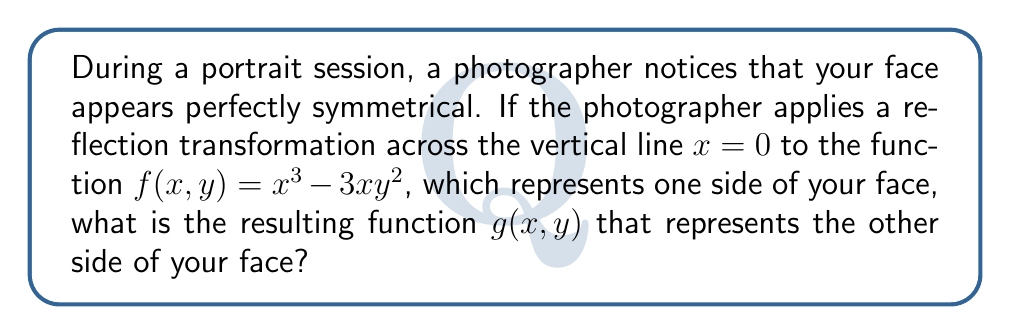Could you help me with this problem? Let's approach this step-by-step:

1) The reflection transformation across the y-axis (the line $x=0$) changes the sign of the x-coordinate while leaving the y-coordinate unchanged. This means we replace every $x$ with $-x$ in the original function.

2) The original function is $f(x,y) = x^3 - 3xy^2$

3) Let's apply the transformation:
   - $x^3$ becomes $(-x)^3 = -x^3$
   - $-3xy^2$ becomes $-3(-x)y^2 = 3xy^2$

4) Combining these terms, we get:
   $$g(x,y) = -x^3 + 3xy^2$$

5) We can factor out $-1$ to get a more compact form:
   $$g(x,y) = -(x^3 - 3xy^2)$$

6) Notice that this is the negative of the original function $f(x,y)$

Therefore, the resulting function $g(x,y)$ that represents the other side of the face after the reflection transformation is $-(x^3 - 3xy^2)$ or $-f(x,y)$.
Answer: $g(x,y) = -(x^3 - 3xy^2)$ 